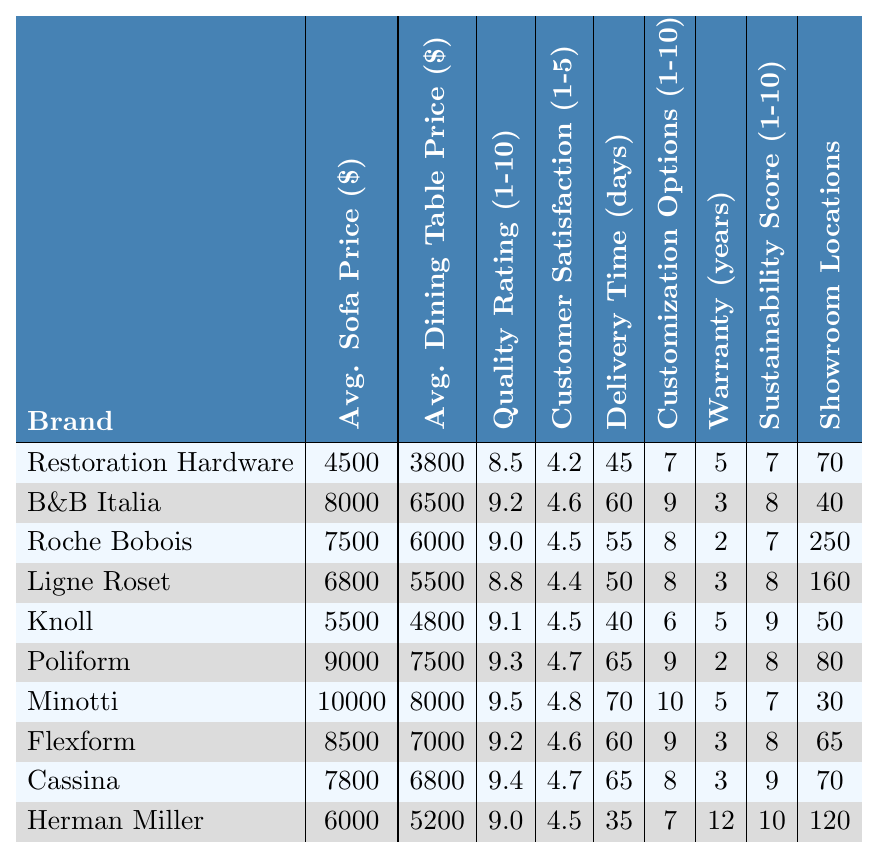What is the average price of a sofa from Flexform? The table shows that the average sofa price for Flexform is listed as 8500.
Answer: 8500 Which brand has the highest warranty period? According to the table, Herman Miller has the highest warranty period, which is 12 years.
Answer: 12 years What is the customer satisfaction score for Cassina? The table indicates that Cassina has a customer satisfaction score of 4.7.
Answer: 4.7 Which brand has the lowest average dining table price? When comparing the average dining table prices, Knoll has the lowest price at 4800.
Answer: 4800 What is the average quality rating among all brands? To find the average quality rating, sum all quality ratings and divide by the total number of brands: (8.5 + 9.2 + 9.0 + 8.8 + 9.1 + 9.3 + 9.5 + 9.2 + 9.4 + 9.0) / 10 = 9.1.
Answer: 9.1 Does B&B Italia have more customization options than Knoll? The table shows B&B Italia has 9 customization options, while Knoll has 6 options, so yes.
Answer: Yes How long does it take on average to deliver a product from Poliform? According to the data, the delivery time for Poliform is listed as 65 days.
Answer: 65 days Which brand has both the highest sustainability score and the most showroom locations? The table shows that Herman Miller has the highest sustainability score of 10 and also has 120 showroom locations, so it meets both criteria.
Answer: Herman Miller What is the difference in average sofa price between Restoration Hardware and Minotti? Restoration Hardware's average sofa price is 4500, and Minotti's is 10000. The difference is 10000 - 4500 = 5500.
Answer: 5500 Is the customer satisfaction score of Flexform greater than 4.5? The table indicates Flexform has a customer satisfaction score of 4.6, which is indeed greater than 4.5.
Answer: Yes 